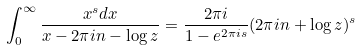<formula> <loc_0><loc_0><loc_500><loc_500>\int _ { 0 } ^ { \infty } \frac { x ^ { s } d x } { x - 2 \pi i n - \log z } = \frac { 2 \pi i } { 1 - e ^ { 2 \pi i s } } ( 2 \pi i n + \log z ) ^ { s }</formula> 